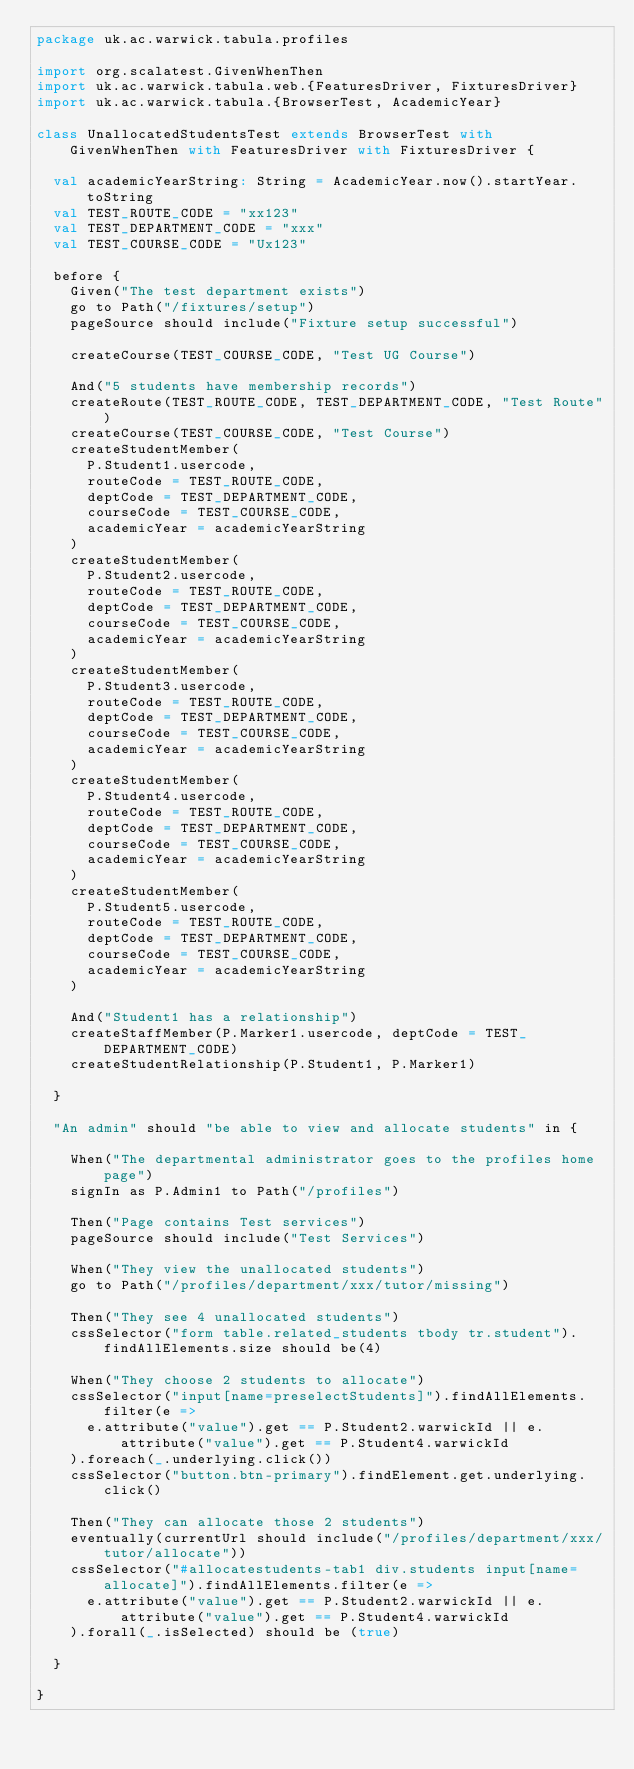Convert code to text. <code><loc_0><loc_0><loc_500><loc_500><_Scala_>package uk.ac.warwick.tabula.profiles

import org.scalatest.GivenWhenThen
import uk.ac.warwick.tabula.web.{FeaturesDriver, FixturesDriver}
import uk.ac.warwick.tabula.{BrowserTest, AcademicYear}

class UnallocatedStudentsTest extends BrowserTest with GivenWhenThen with FeaturesDriver with FixturesDriver {

  val academicYearString: String = AcademicYear.now().startYear.toString
  val TEST_ROUTE_CODE = "xx123"
  val TEST_DEPARTMENT_CODE = "xxx"
  val TEST_COURSE_CODE = "Ux123"

  before {
    Given("The test department exists")
    go to Path("/fixtures/setup")
    pageSource should include("Fixture setup successful")

    createCourse(TEST_COURSE_CODE, "Test UG Course")

    And("5 students have membership records")
    createRoute(TEST_ROUTE_CODE, TEST_DEPARTMENT_CODE, "Test Route")
    createCourse(TEST_COURSE_CODE, "Test Course")
    createStudentMember(
      P.Student1.usercode,
      routeCode = TEST_ROUTE_CODE,
      deptCode = TEST_DEPARTMENT_CODE,
      courseCode = TEST_COURSE_CODE,
      academicYear = academicYearString
    )
    createStudentMember(
      P.Student2.usercode,
      routeCode = TEST_ROUTE_CODE,
      deptCode = TEST_DEPARTMENT_CODE,
      courseCode = TEST_COURSE_CODE,
      academicYear = academicYearString
    )
    createStudentMember(
      P.Student3.usercode,
      routeCode = TEST_ROUTE_CODE,
      deptCode = TEST_DEPARTMENT_CODE,
      courseCode = TEST_COURSE_CODE,
      academicYear = academicYearString
    )
    createStudentMember(
      P.Student4.usercode,
      routeCode = TEST_ROUTE_CODE,
      deptCode = TEST_DEPARTMENT_CODE,
      courseCode = TEST_COURSE_CODE,
      academicYear = academicYearString
    )
    createStudentMember(
      P.Student5.usercode,
      routeCode = TEST_ROUTE_CODE,
      deptCode = TEST_DEPARTMENT_CODE,
      courseCode = TEST_COURSE_CODE,
      academicYear = academicYearString
    )

    And("Student1 has a relationship")
    createStaffMember(P.Marker1.usercode, deptCode = TEST_DEPARTMENT_CODE)
    createStudentRelationship(P.Student1, P.Marker1)

  }

  "An admin" should "be able to view and allocate students" in {

    When("The departmental administrator goes to the profiles home page")
    signIn as P.Admin1 to Path("/profiles")

    Then("Page contains Test services")
    pageSource should include("Test Services")

    When("They view the unallocated students")
    go to Path("/profiles/department/xxx/tutor/missing")

    Then("They see 4 unallocated students")
    cssSelector("form table.related_students tbody tr.student").findAllElements.size should be(4)

    When("They choose 2 students to allocate")
    cssSelector("input[name=preselectStudents]").findAllElements.filter(e =>
      e.attribute("value").get == P.Student2.warwickId || e.attribute("value").get == P.Student4.warwickId
    ).foreach(_.underlying.click())
    cssSelector("button.btn-primary").findElement.get.underlying.click()

    Then("They can allocate those 2 students")
    eventually(currentUrl should include("/profiles/department/xxx/tutor/allocate"))
    cssSelector("#allocatestudents-tab1 div.students input[name=allocate]").findAllElements.filter(e =>
      e.attribute("value").get == P.Student2.warwickId || e.attribute("value").get == P.Student4.warwickId
    ).forall(_.isSelected) should be (true)

  }

}
</code> 